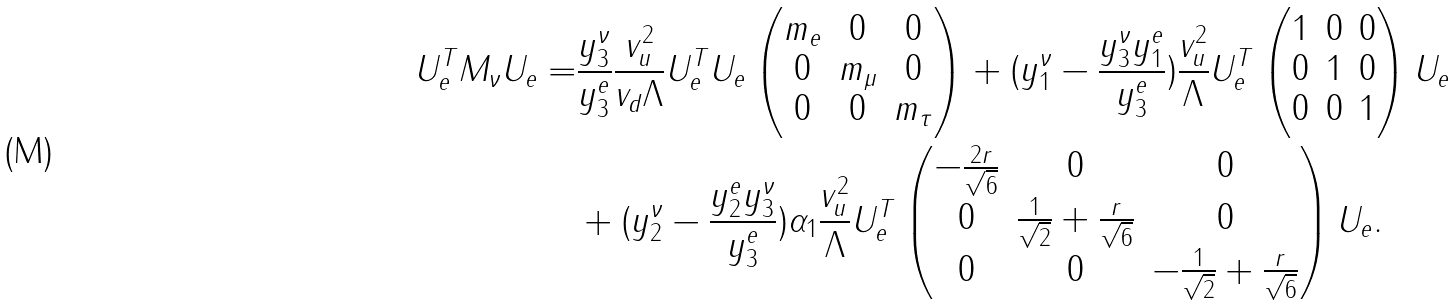<formula> <loc_0><loc_0><loc_500><loc_500>U _ { e } ^ { T } M _ { \nu } U _ { e } = & \frac { y _ { 3 } ^ { \nu } } { y _ { 3 } ^ { e } } \frac { v _ { u } ^ { 2 } } { v _ { d } \Lambda } U _ { e } ^ { T } U _ { e } \begin{pmatrix} m _ { e } & 0 & 0 \\ 0 & m _ { \mu } & 0 \\ 0 & 0 & m _ { \tau } \end{pmatrix} + ( y _ { 1 } ^ { \nu } - \frac { y _ { 3 } ^ { \nu } y _ { 1 } ^ { e } } { y _ { 3 } ^ { e } } ) \frac { v _ { u } ^ { 2 } } { \Lambda } U _ { e } ^ { T } \begin{pmatrix} 1 & 0 & 0 \\ 0 & 1 & 0 \\ 0 & 0 & 1 \\ \end{pmatrix} U _ { e } \\ & + ( y _ { 2 } ^ { \nu } - \frac { y _ { 2 } ^ { e } y _ { 3 } ^ { \nu } } { y _ { 3 } ^ { e } } ) \alpha _ { 1 } \frac { v _ { u } ^ { 2 } } { \Lambda } U _ { e } ^ { T } \begin{pmatrix} - \frac { 2 r } { \sqrt { 6 } } & 0 & 0 \\ 0 & \frac { 1 } { \sqrt { 2 } } + \frac { r } { \sqrt { 6 } } & 0 \\ 0 & 0 & - \frac { 1 } { \sqrt { 2 } } + \frac { r } { \sqrt { 6 } } \\ \end{pmatrix} U _ { e } .</formula> 